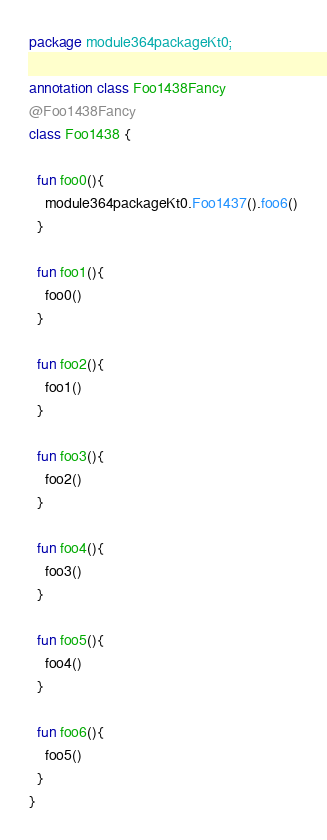<code> <loc_0><loc_0><loc_500><loc_500><_Kotlin_>package module364packageKt0;

annotation class Foo1438Fancy
@Foo1438Fancy
class Foo1438 {

  fun foo0(){
    module364packageKt0.Foo1437().foo6()
  }

  fun foo1(){
    foo0()
  }

  fun foo2(){
    foo1()
  }

  fun foo3(){
    foo2()
  }

  fun foo4(){
    foo3()
  }

  fun foo5(){
    foo4()
  }

  fun foo6(){
    foo5()
  }
}</code> 